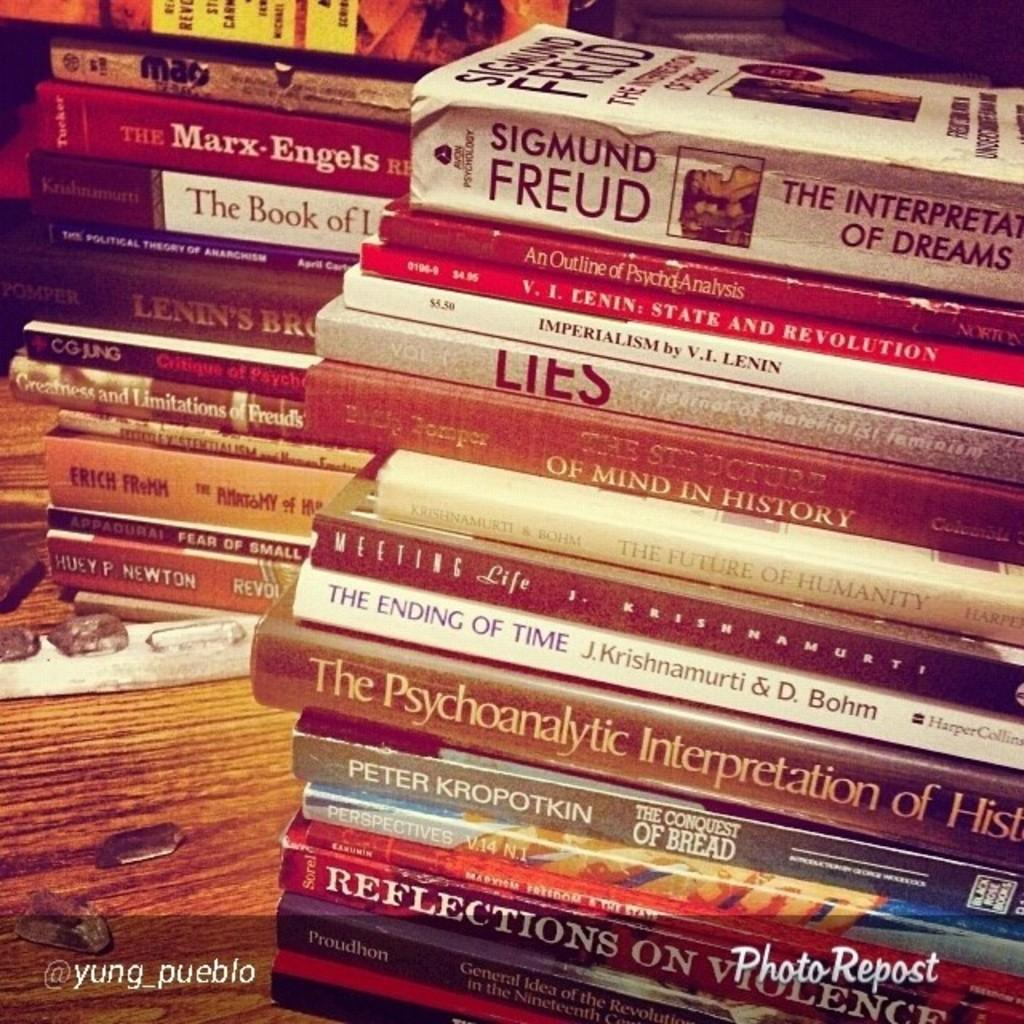Provide a one-sentence caption for the provided image. A stack of books has one written by Freud at the top. 